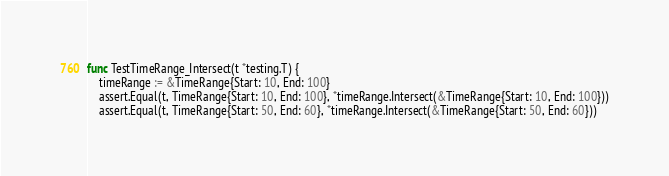Convert code to text. <code><loc_0><loc_0><loc_500><loc_500><_Go_>func TestTimeRange_Intersect(t *testing.T) {
	timeRange := &TimeRange{Start: 10, End: 100}
	assert.Equal(t, TimeRange{Start: 10, End: 100}, *timeRange.Intersect(&TimeRange{Start: 10, End: 100}))
	assert.Equal(t, TimeRange{Start: 50, End: 60}, *timeRange.Intersect(&TimeRange{Start: 50, End: 60}))</code> 